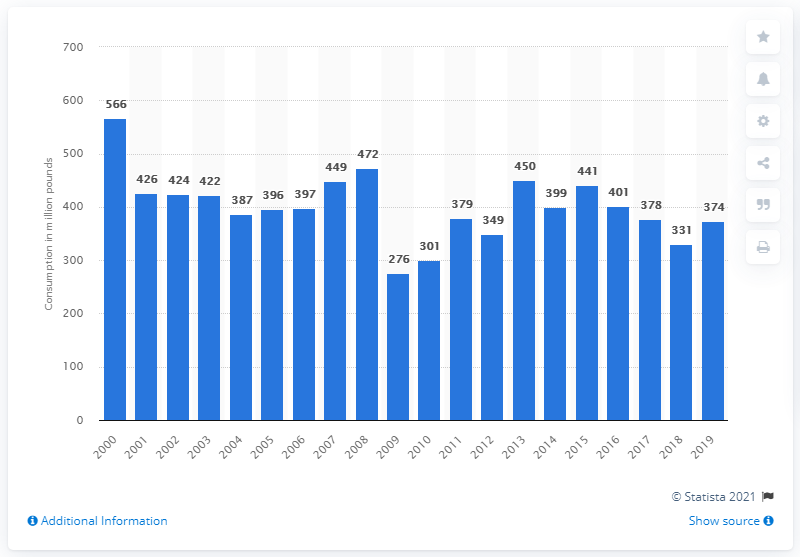Outline some significant characteristics in this image. The total consumption of frozen yogurt in the United States in 2017 was 378 million servings. 